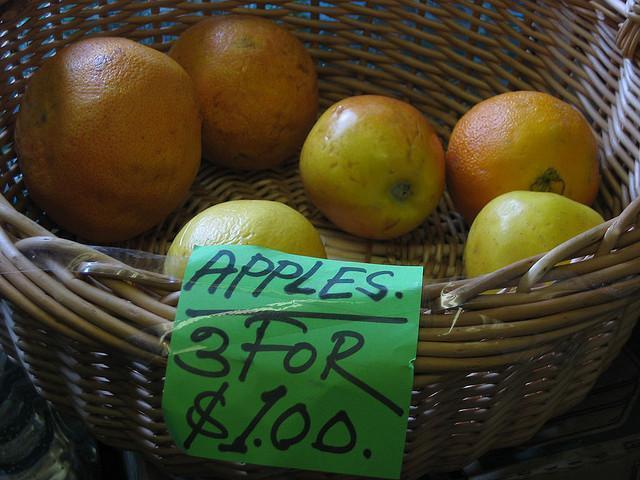How many apples are there?
Give a very brief answer. 3. How many oranges can you see?
Give a very brief answer. 5. 